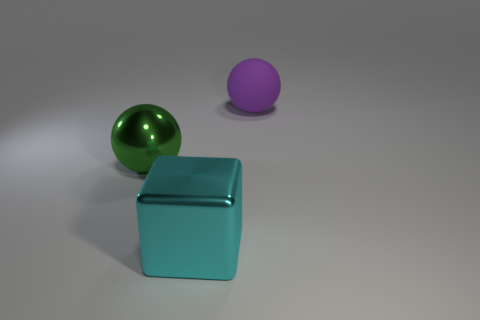Add 3 yellow rubber blocks. How many objects exist? 6 Subtract all cubes. How many objects are left? 2 Subtract all large green metal balls. Subtract all cyan blocks. How many objects are left? 1 Add 1 purple rubber balls. How many purple rubber balls are left? 2 Add 2 green matte things. How many green matte things exist? 2 Subtract 0 cyan balls. How many objects are left? 3 